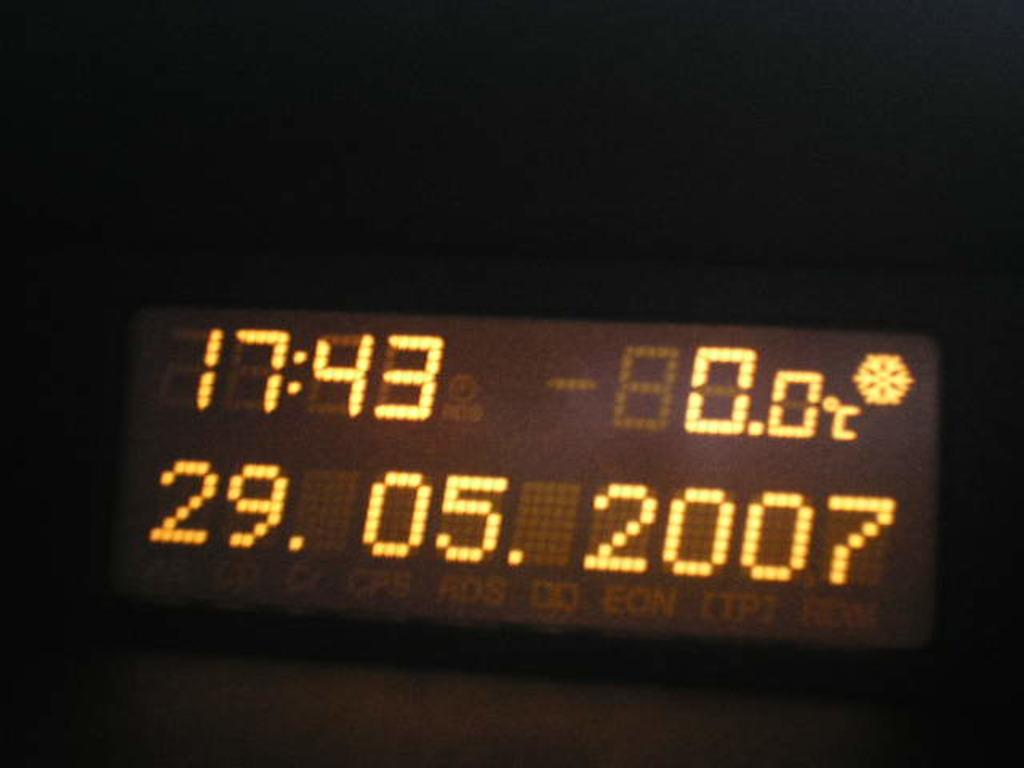<image>
Create a compact narrative representing the image presented. A digital clock reads 17:43 0 degrees on 29.05.2017 in yellow letters. 